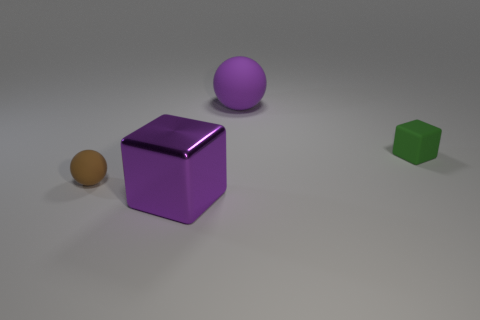Add 1 tiny brown shiny balls. How many objects exist? 5 Add 4 small green objects. How many small green objects exist? 5 Subtract 0 blue cylinders. How many objects are left? 4 Subtract all tiny gray balls. Subtract all tiny matte things. How many objects are left? 2 Add 1 brown spheres. How many brown spheres are left? 2 